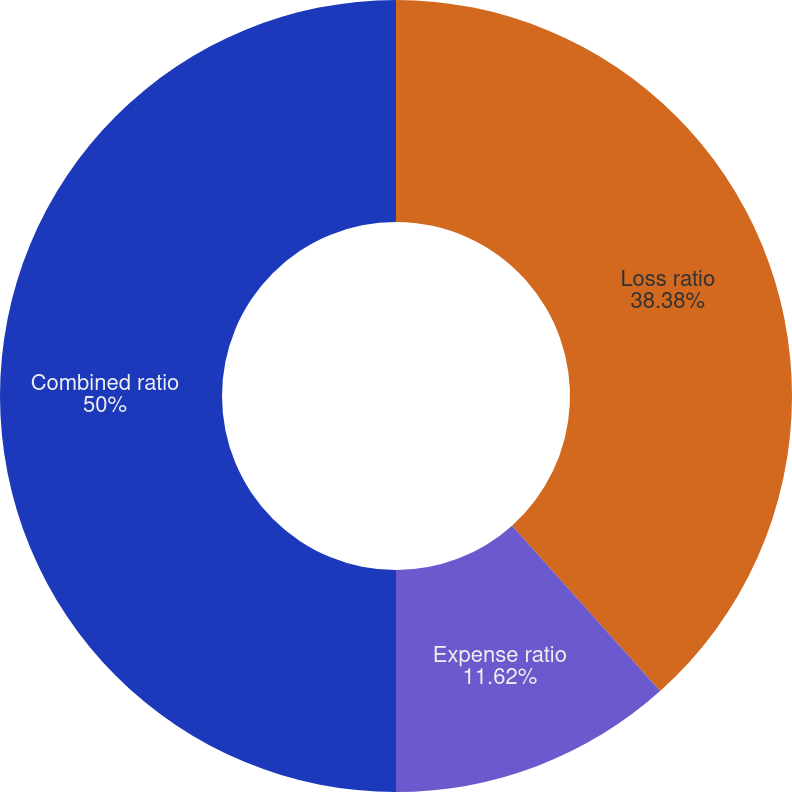Convert chart to OTSL. <chart><loc_0><loc_0><loc_500><loc_500><pie_chart><fcel>Loss ratio<fcel>Expense ratio<fcel>Combined ratio<nl><fcel>38.38%<fcel>11.62%<fcel>50.0%<nl></chart> 